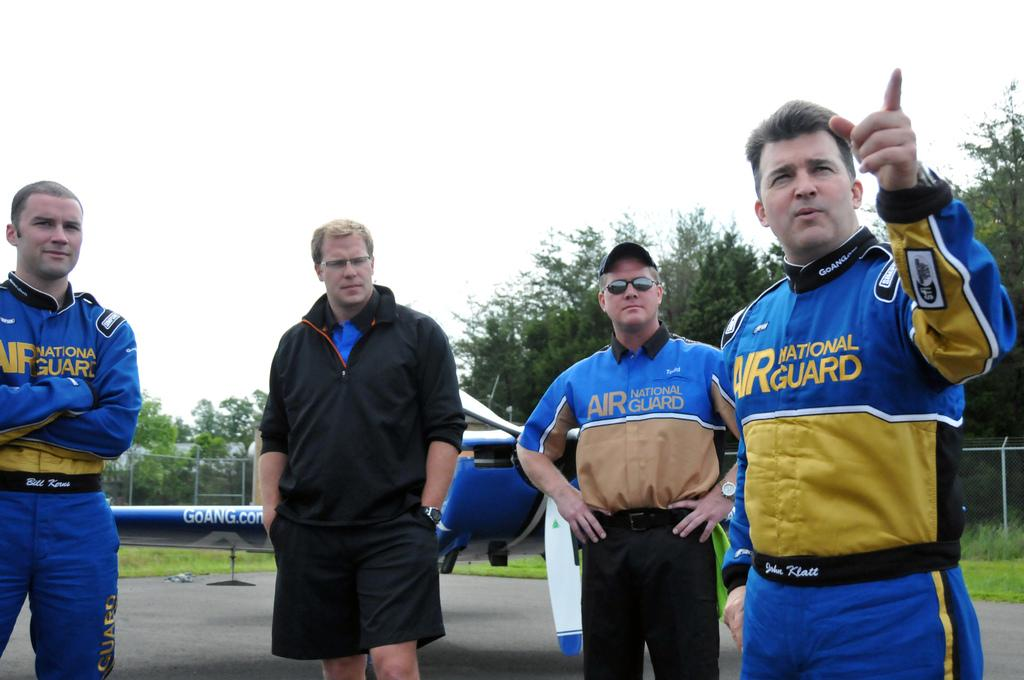Provide a one-sentence caption for the provided image. Several men are wearing blue uniforms for the Air National Guard. 